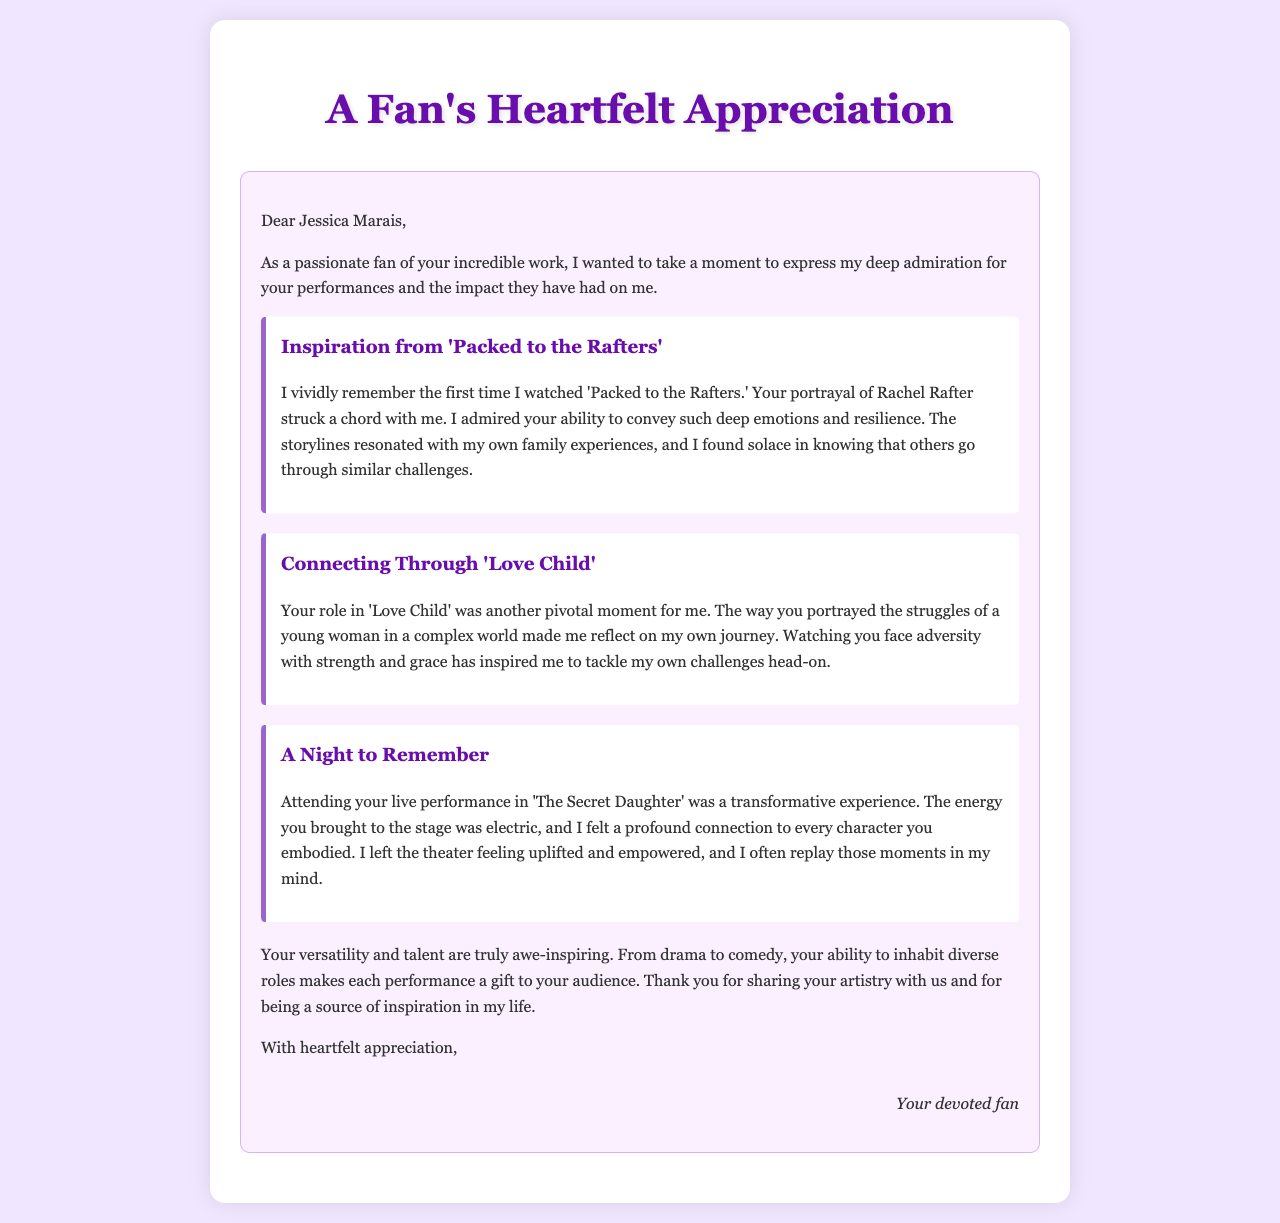What is the title of the document? The title of the document is located in the `<title>` tag in the header section.
Answer: Fan Appreciation Letter to Jessica Marais Who is the letter addressed to? The recipient of the letter is mentioned in the first paragraph.
Answer: Jessica Marais What series is mentioned as the first anecdote? The first anecdote refers to a specific series in the document.
Answer: Packed to the Rafters What role did Jessica Marais play in 'Love Child'? The document discusses her performance in 'Love Child' but does not specify her character's name.
Answer: Unknown What type of performance did the author attend? The author describes attending a specific type of performance in the letter.
Answer: Live performance How does the author feel after watching 'The Secret Daughter'? The author expresses their feelings about the performance in a specific way.
Answer: Uplifted and empowered What color is the background of the document? The background color of the document can be found in the CSS styling.
Answer: #f0e6ff How many anecdotes are included in the letter? The total number of anecdotes is counted from the sections provided in the letter content.
Answer: Three 